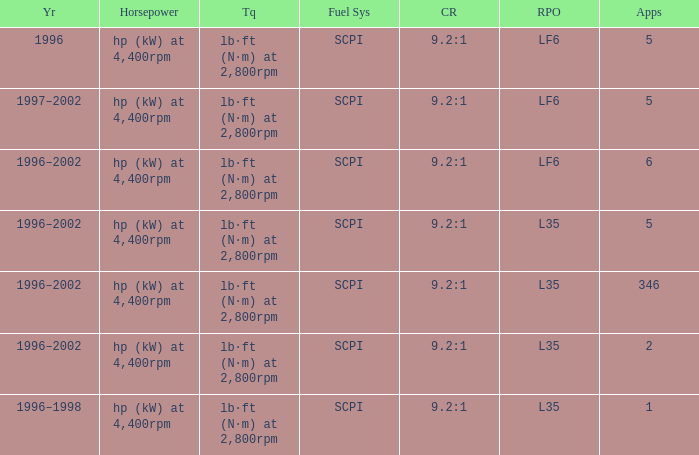What are the torque characteristics of the model made in 1996? Lb·ft (n·m) at 2,800rpm. 